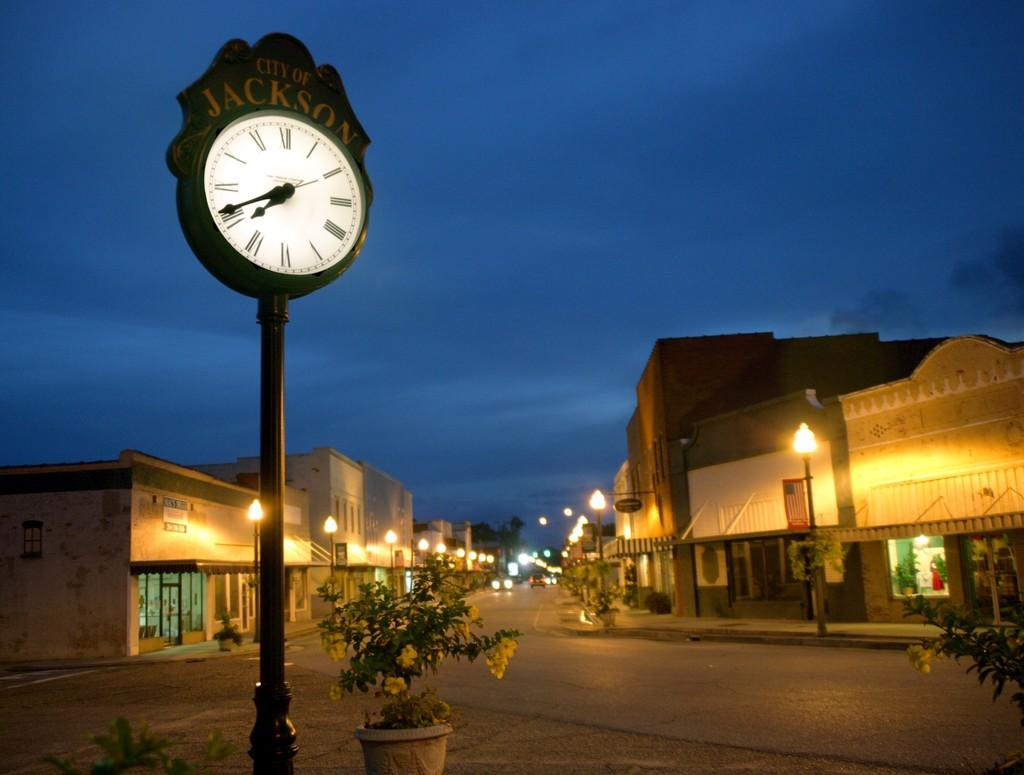What type of structures can be seen in the image? There are buildings in the image. What objects are present to provide illumination in the image? There are light poles in the image. What type of decorative items are visible in the image? There are flowerpots in the image. What type of pathway is present in the image? There is a road in the image. What type of vertical structure is present in the image? There is a pole in the image. What type of timekeeping device is visible in the image? There is a clock in the image. What part of the natural environment is visible in the image? The sky is visible in the image. What type of transportation is present on the road in the image? There are vehicles on the road in the image. What type of noise can be heard coming from the beggar in the image? There is no beggar present in the image, so no noise can be heard from a beggar. What type of pleasure can be seen on the faces of the people in the image? There are no people visible in the image, so their facial expressions and any associated pleasure cannot be determined. 